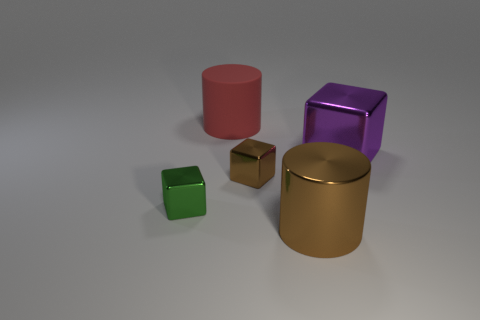Subtract all tiny blocks. How many blocks are left? 1 Add 1 tiny metallic things. How many objects exist? 6 Subtract all red cylinders. How many cylinders are left? 1 Subtract all cubes. How many objects are left? 2 Add 5 tiny green blocks. How many tiny green blocks exist? 6 Subtract 1 purple cubes. How many objects are left? 4 Subtract 3 cubes. How many cubes are left? 0 Subtract all red cylinders. Subtract all green cubes. How many cylinders are left? 1 Subtract all green blocks. How many red cylinders are left? 1 Subtract all tiny brown metallic objects. Subtract all green metallic objects. How many objects are left? 3 